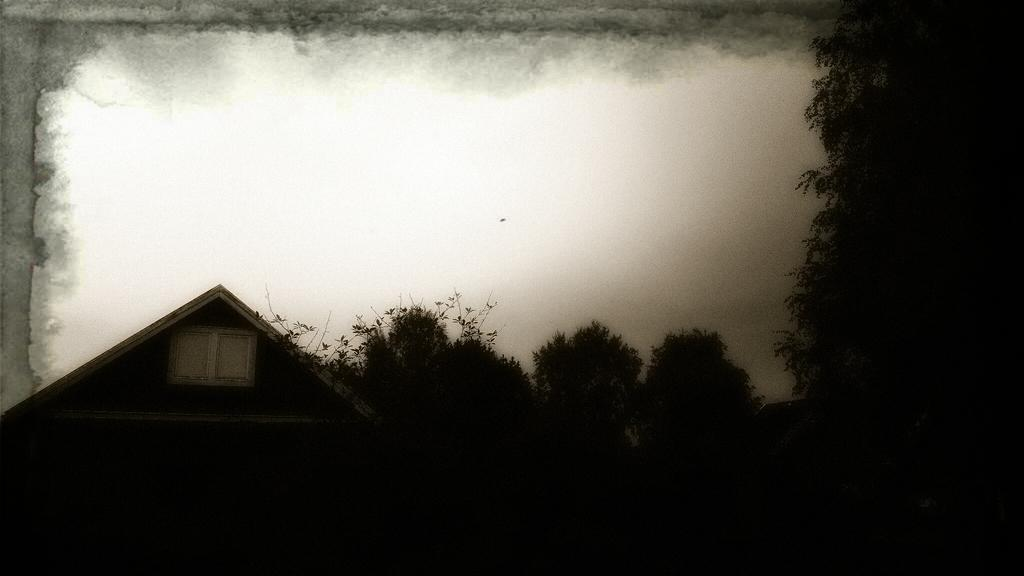What is the color scheme of the image? The image is black and white. What can be seen in the foreground of the image? There are trees and a house in the foreground of the image. What is the main focus of the image? The center of the image contains the sky. Has the image been altered in any way? Yes, the image has been edited. How does the image provide comfort to the viewer? The image does not provide comfort to the viewer, as it is a still image and cannot offer any physical comfort. 